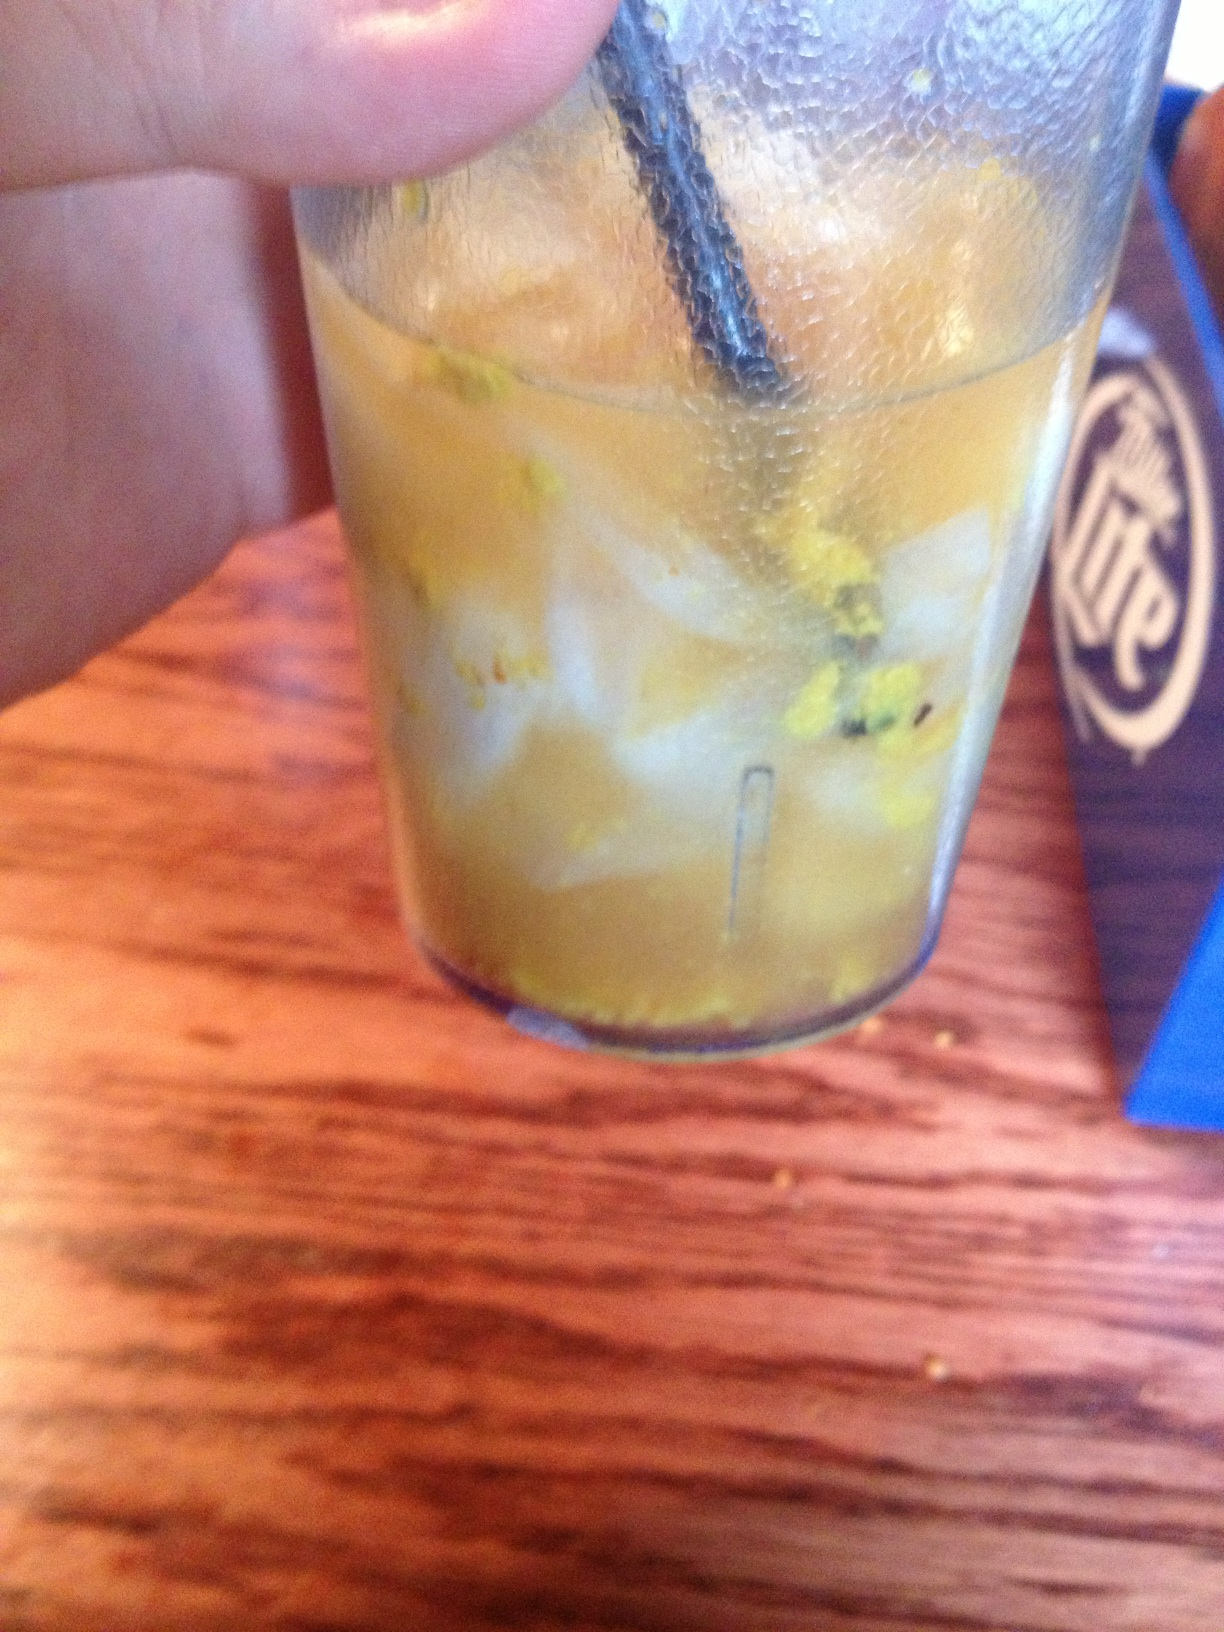This drink makes me think of a wizard's potion. What imaginative descriptions can you come up with for it? Ah, a true alchemist's creation! Picture this - a bubbling brew containing the essence of the sun, captured in golden shreds of mythical citrus from the enchanted groves. The drink is enchanted with crushed stardust and gleams with the promise of magical adventures. Raise the glass and savor the fragrant notes of this mystical elixir, brewed for only the bravest of souls. What kind of magical creature would drink this potion? This sparkling elixir is surely favored by the mystical dragicorn, a creature with the strength of dragons and the elegance of unicorns. Known for its shimmering scales and its love for all things gilded, the dragicorn would sip this potion to keep its magic sharp and its spirit adventurous. Legend has it, drinking this enchanted brew grants the gift of flight and the wisdom of centuries past. 